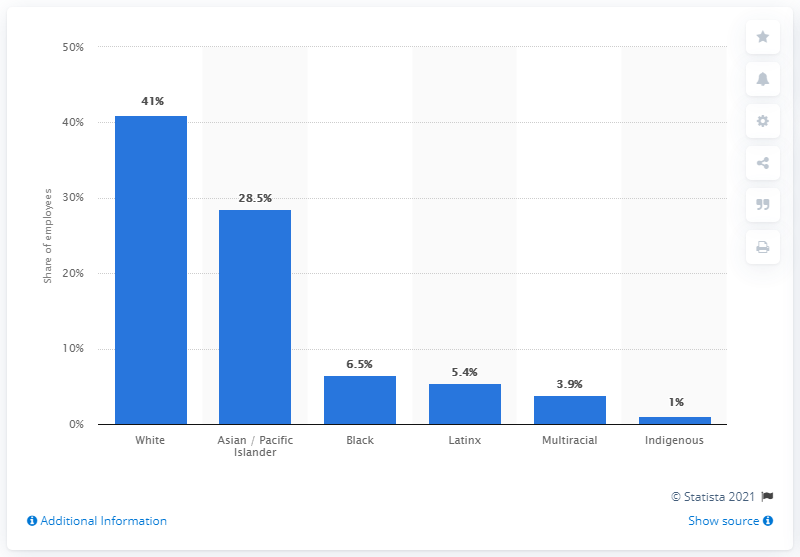Give some essential details in this illustration. According to a recent study, 5.4% of Twitter employees identified as Latinx, which is a term used to describe people of Latin American or Hispanic descent. 